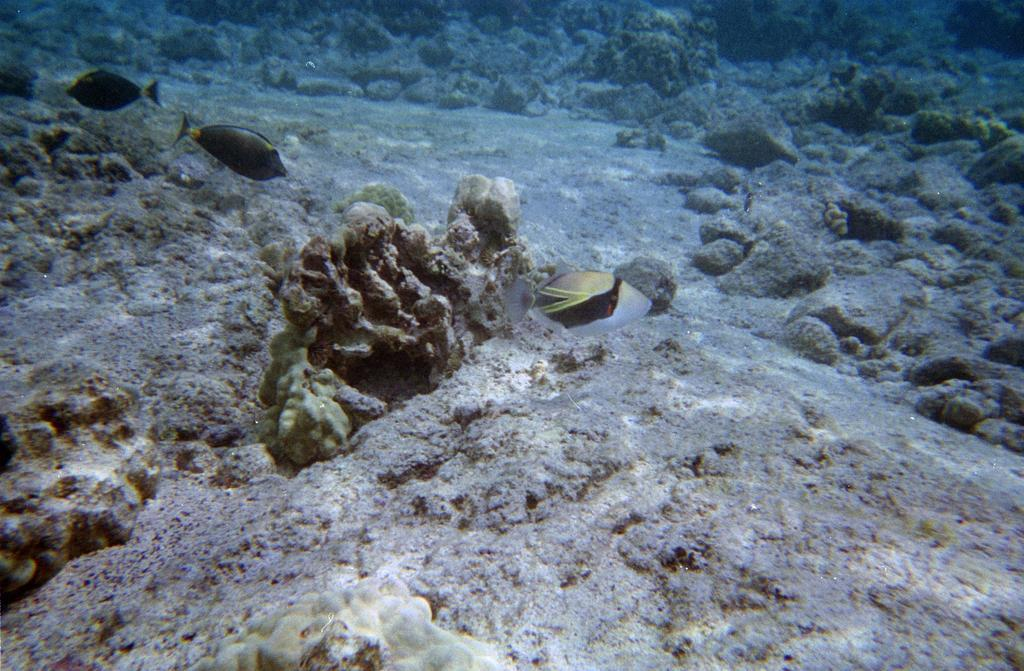What type of animals can be seen in the image? There are fishes in the image. Can you describe the appearance of the fishes? The fishes are multicolored. What is the primary element in which the fishes are situated? There is water visible in the image. What other objects can be seen in the image? There are stones in the image. What type of stitch is being used to sew the tongue of the fish in the image? There is no indication in the image that any fish has a tongue, nor is there any stitching visible. 